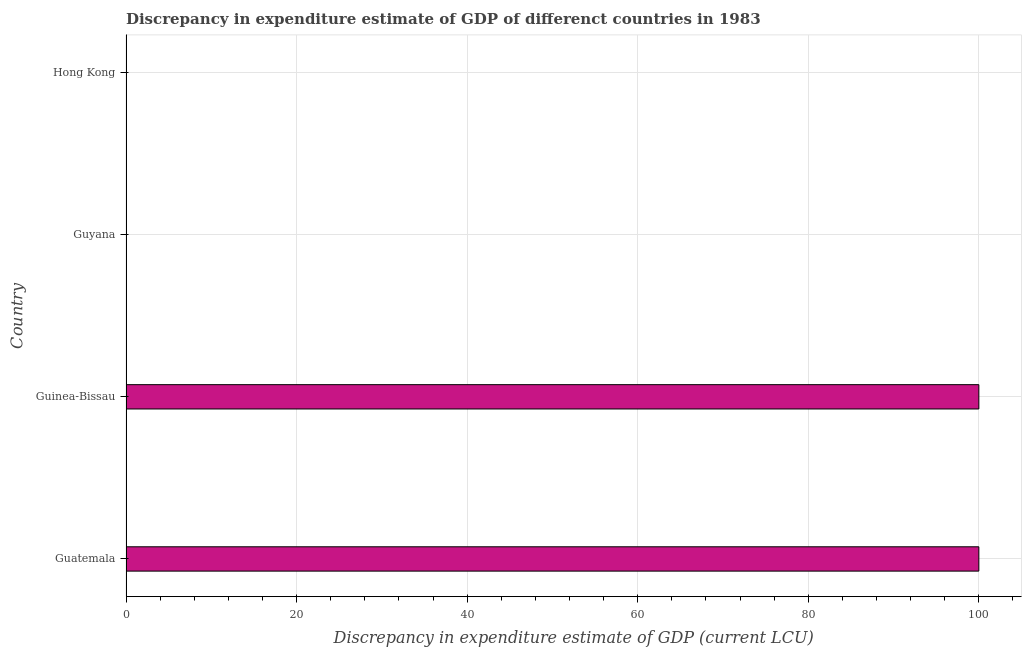Does the graph contain any zero values?
Give a very brief answer. No. Does the graph contain grids?
Your answer should be compact. Yes. What is the title of the graph?
Ensure brevity in your answer.  Discrepancy in expenditure estimate of GDP of differenct countries in 1983. What is the label or title of the X-axis?
Keep it short and to the point. Discrepancy in expenditure estimate of GDP (current LCU). What is the label or title of the Y-axis?
Ensure brevity in your answer.  Country. What is the discrepancy in expenditure estimate of gdp in Guyana?
Provide a short and direct response. 6e-8. Across all countries, what is the maximum discrepancy in expenditure estimate of gdp?
Make the answer very short. 100. Across all countries, what is the minimum discrepancy in expenditure estimate of gdp?
Your answer should be compact. 6e-8. In which country was the discrepancy in expenditure estimate of gdp maximum?
Give a very brief answer. Guatemala. In which country was the discrepancy in expenditure estimate of gdp minimum?
Keep it short and to the point. Guyana. What is the sum of the discrepancy in expenditure estimate of gdp?
Your answer should be compact. 200. What is the difference between the discrepancy in expenditure estimate of gdp in Guatemala and Hong Kong?
Give a very brief answer. 100. What is the average discrepancy in expenditure estimate of gdp per country?
Provide a succinct answer. 50. What is the median discrepancy in expenditure estimate of gdp?
Your answer should be very brief. 50. In how many countries, is the discrepancy in expenditure estimate of gdp greater than 84 LCU?
Offer a very short reply. 2. What is the ratio of the discrepancy in expenditure estimate of gdp in Guatemala to that in Guyana?
Your response must be concise. 1.67e+09. Is the discrepancy in expenditure estimate of gdp in Guatemala less than that in Guinea-Bissau?
Your response must be concise. No. Is the difference between the discrepancy in expenditure estimate of gdp in Guinea-Bissau and Hong Kong greater than the difference between any two countries?
Ensure brevity in your answer.  No. What is the difference between the highest and the second highest discrepancy in expenditure estimate of gdp?
Your answer should be very brief. 0. Is the sum of the discrepancy in expenditure estimate of gdp in Guatemala and Guinea-Bissau greater than the maximum discrepancy in expenditure estimate of gdp across all countries?
Your response must be concise. Yes. What is the difference between the highest and the lowest discrepancy in expenditure estimate of gdp?
Offer a very short reply. 100. In how many countries, is the discrepancy in expenditure estimate of gdp greater than the average discrepancy in expenditure estimate of gdp taken over all countries?
Provide a short and direct response. 2. How many bars are there?
Provide a short and direct response. 4. What is the Discrepancy in expenditure estimate of GDP (current LCU) in Guatemala?
Give a very brief answer. 100. What is the Discrepancy in expenditure estimate of GDP (current LCU) in Guyana?
Ensure brevity in your answer.  6e-8. What is the Discrepancy in expenditure estimate of GDP (current LCU) in Hong Kong?
Keep it short and to the point. 3e-5. What is the difference between the Discrepancy in expenditure estimate of GDP (current LCU) in Guatemala and Hong Kong?
Offer a very short reply. 100. What is the difference between the Discrepancy in expenditure estimate of GDP (current LCU) in Guinea-Bissau and Guyana?
Make the answer very short. 100. What is the difference between the Discrepancy in expenditure estimate of GDP (current LCU) in Guinea-Bissau and Hong Kong?
Provide a succinct answer. 100. What is the difference between the Discrepancy in expenditure estimate of GDP (current LCU) in Guyana and Hong Kong?
Give a very brief answer. -3e-5. What is the ratio of the Discrepancy in expenditure estimate of GDP (current LCU) in Guatemala to that in Guinea-Bissau?
Your answer should be very brief. 1. What is the ratio of the Discrepancy in expenditure estimate of GDP (current LCU) in Guatemala to that in Guyana?
Offer a very short reply. 1.67e+09. What is the ratio of the Discrepancy in expenditure estimate of GDP (current LCU) in Guatemala to that in Hong Kong?
Offer a terse response. 3.33e+06. What is the ratio of the Discrepancy in expenditure estimate of GDP (current LCU) in Guinea-Bissau to that in Guyana?
Offer a very short reply. 1.67e+09. What is the ratio of the Discrepancy in expenditure estimate of GDP (current LCU) in Guinea-Bissau to that in Hong Kong?
Your answer should be compact. 3.33e+06. What is the ratio of the Discrepancy in expenditure estimate of GDP (current LCU) in Guyana to that in Hong Kong?
Make the answer very short. 0. 